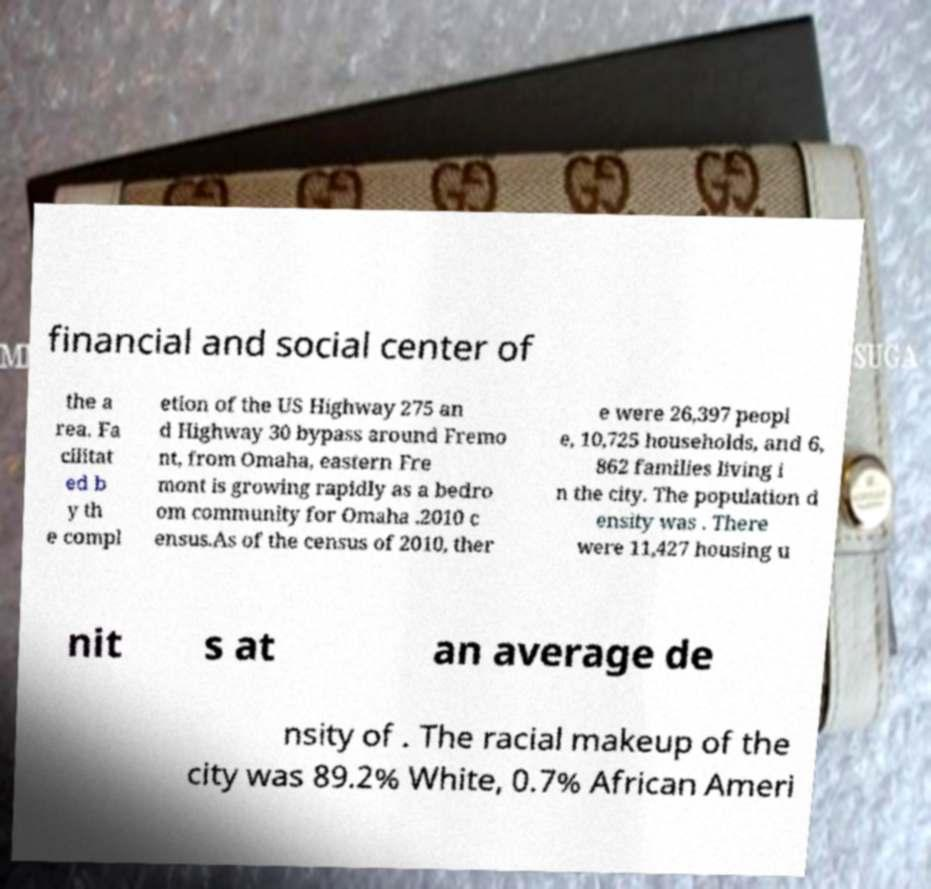Could you assist in decoding the text presented in this image and type it out clearly? financial and social center of the a rea. Fa cilitat ed b y th e compl etion of the US Highway 275 an d Highway 30 bypass around Fremo nt, from Omaha, eastern Fre mont is growing rapidly as a bedro om community for Omaha .2010 c ensus.As of the census of 2010, ther e were 26,397 peopl e, 10,725 households, and 6, 862 families living i n the city. The population d ensity was . There were 11,427 housing u nit s at an average de nsity of . The racial makeup of the city was 89.2% White, 0.7% African Ameri 